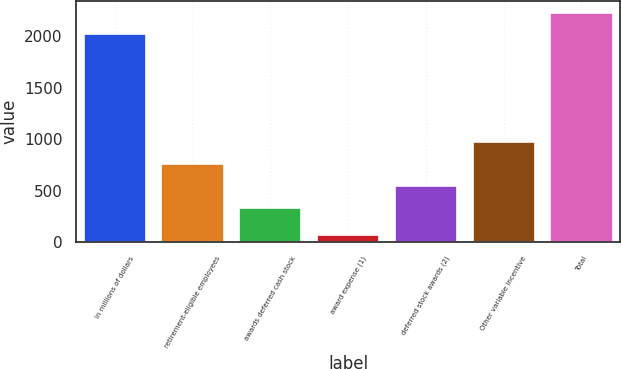Convert chart to OTSL. <chart><loc_0><loc_0><loc_500><loc_500><bar_chart><fcel>In millions of dollars<fcel>retirement-eligible employees<fcel>awards deferred cash stock<fcel>award expense (1)<fcel>deferred stock awards (2)<fcel>Other variable incentive<fcel>Total<nl><fcel>2016<fcel>758<fcel>336<fcel>73<fcel>547<fcel>969<fcel>2227<nl></chart> 